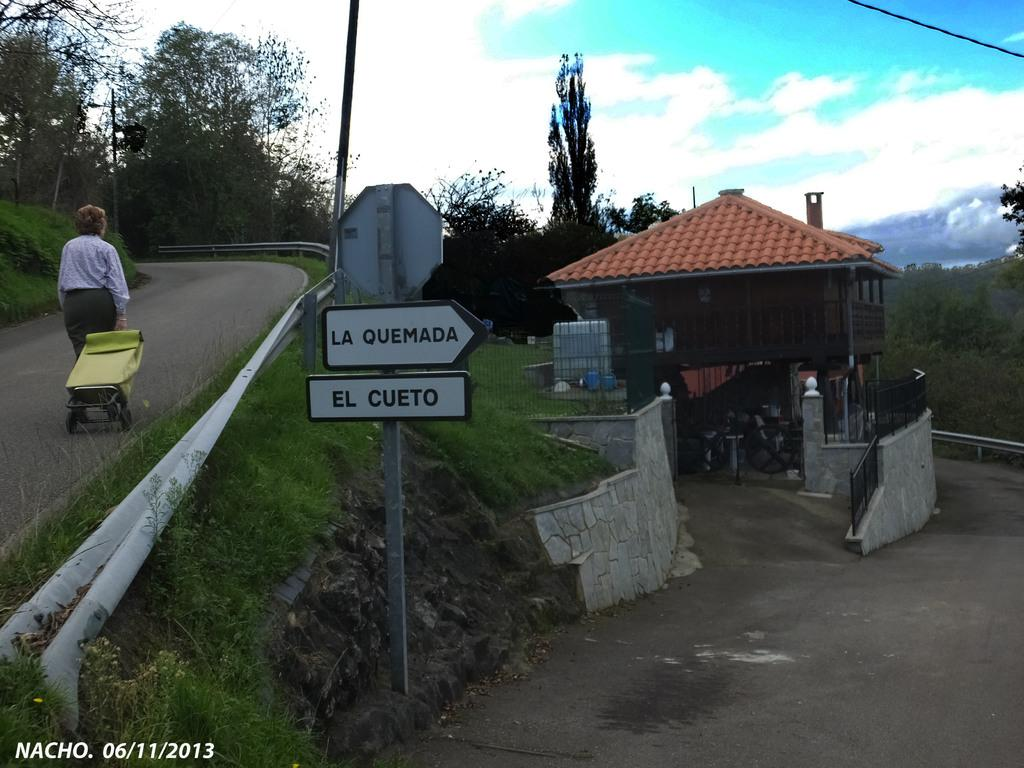What type of vegetation can be seen in the image? There is grass in the image. What structure is present in the image? There is a house in the image. What else can be seen in the image besides the house? There is a sign pole and trees in the image. Who is present in the image? There is a woman holding a suitcase in the image. What is the woman doing in the image? The woman is walking in the image. What is visible in the sky in the image? The sky is visible in the image, and clouds are present. What type of whip is the woman using to guide the clouds in the image? There is no whip present in the image, and the woman is not guiding any clouds. What rule does the sign pole enforce in the image? The sign pole does not enforce any rules in the image; it is simply a structure in the scene. 